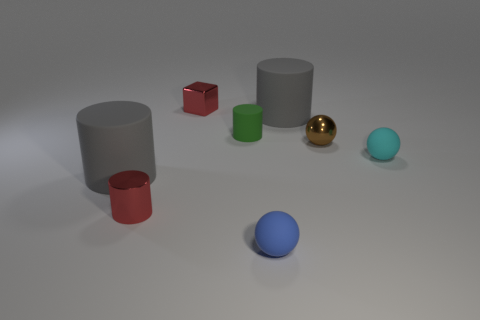How many metallic things are small cyan cylinders or tiny red cylinders?
Give a very brief answer. 1. What number of large green rubber cylinders are there?
Offer a terse response. 0. What is the color of the metal sphere that is the same size as the green matte object?
Your answer should be compact. Brown. Is the shiny cylinder the same size as the green cylinder?
Offer a very short reply. Yes. The object that is the same color as the tiny metal cube is what shape?
Provide a short and direct response. Cylinder. Does the blue sphere have the same size as the gray thing on the right side of the blue rubber ball?
Keep it short and to the point. No. There is a small rubber thing that is both on the left side of the small cyan sphere and on the right side of the green rubber object; what color is it?
Ensure brevity in your answer.  Blue. Are there more gray objects in front of the metallic cylinder than small brown balls that are in front of the cyan rubber object?
Your answer should be compact. No. How many large gray cylinders are right of the blue matte thing that is on the left side of the small brown ball?
Your answer should be very brief. 1. Are there any tiny blue matte objects of the same shape as the small brown object?
Keep it short and to the point. Yes. 